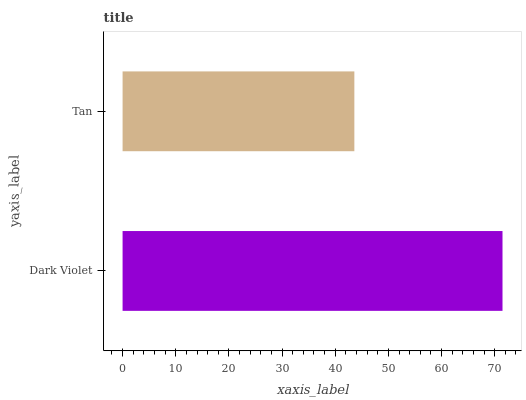Is Tan the minimum?
Answer yes or no. Yes. Is Dark Violet the maximum?
Answer yes or no. Yes. Is Tan the maximum?
Answer yes or no. No. Is Dark Violet greater than Tan?
Answer yes or no. Yes. Is Tan less than Dark Violet?
Answer yes or no. Yes. Is Tan greater than Dark Violet?
Answer yes or no. No. Is Dark Violet less than Tan?
Answer yes or no. No. Is Dark Violet the high median?
Answer yes or no. Yes. Is Tan the low median?
Answer yes or no. Yes. Is Tan the high median?
Answer yes or no. No. Is Dark Violet the low median?
Answer yes or no. No. 